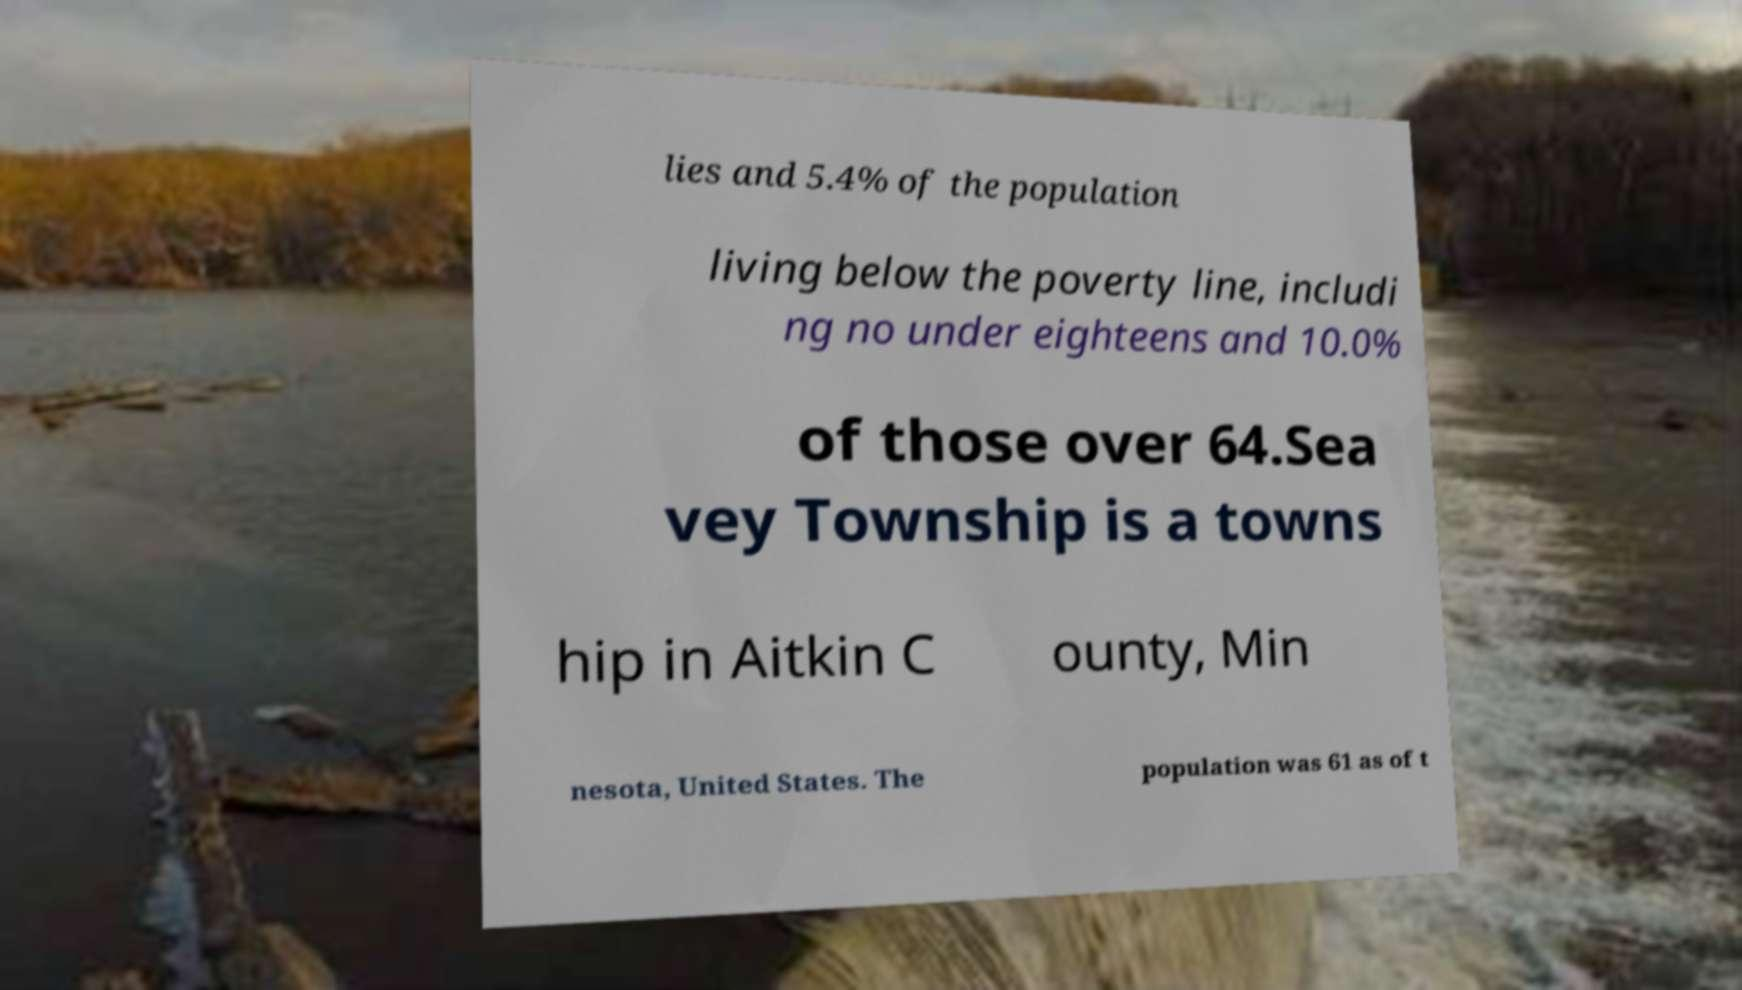I need the written content from this picture converted into text. Can you do that? lies and 5.4% of the population living below the poverty line, includi ng no under eighteens and 10.0% of those over 64.Sea vey Township is a towns hip in Aitkin C ounty, Min nesota, United States. The population was 61 as of t 